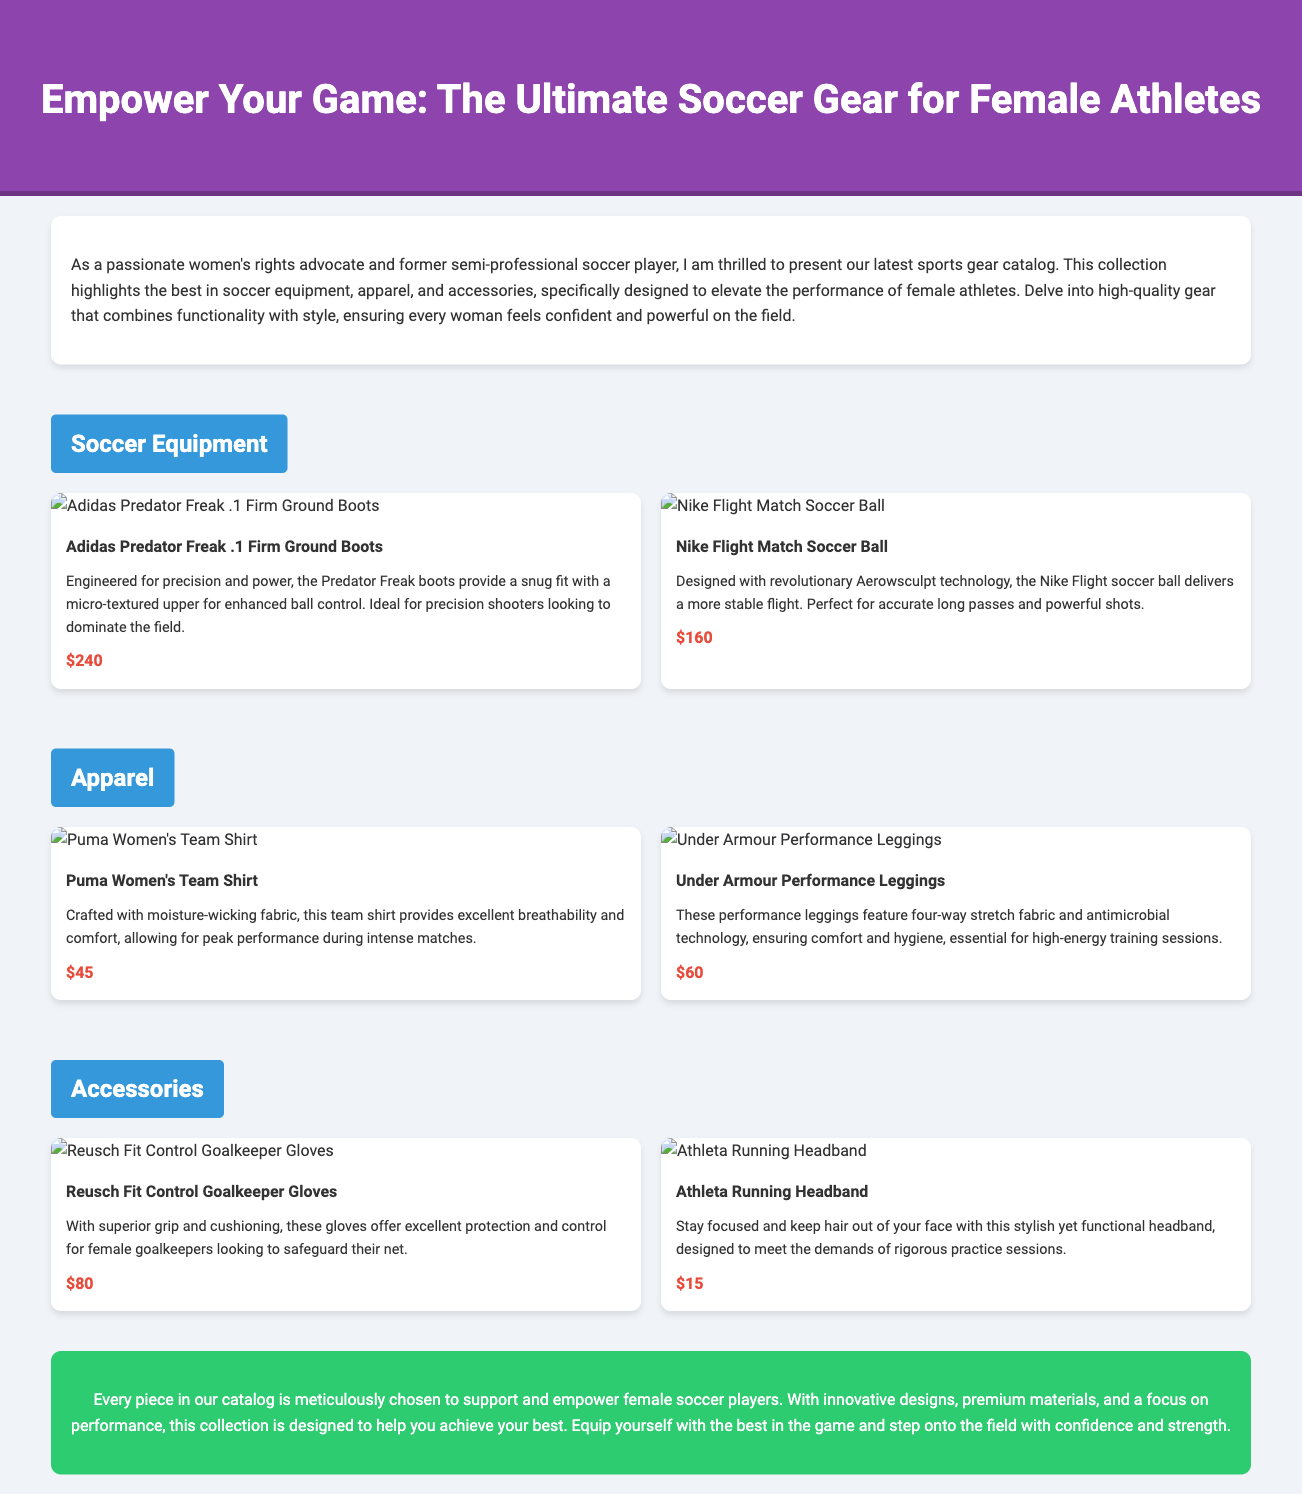What is the title of the catalog? The title is prominently displayed in the header section of the document.
Answer: Empower Your Game: The Ultimate Soccer Gear for Female Athletes How much do the Adidas Predator Freak boots cost? The price is listed under the product information for the Adidas Predator Freak boots.
Answer: $240 What type of technology does the Nike Flight Match soccer ball use? The technology is mentioned in the product description of the Nike Flight Match soccer ball.
Answer: Aerowsculpt technology Which brand offers the performance leggings? The brand name is included in the product title of the performance leggings.
Answer: Under Armour What feature does the Puma Women's Team Shirt highlight? The feature is mentioned in the description focusing on the material of the shirt.
Answer: Moisture-wicking fabric How many product cards are displayed under the Accessories section? The number of product cards can be counted in the Accessories section of the document.
Answer: 2 What is a common purpose of the products featured in this catalog? The overall purpose is detailed in the introductory and conclusion sections of the document.
Answer: Empower female athletes What is the price of the Athleta Running Headband? The price is displayed below the product information for the Athleta Running Headband.
Answer: $15 